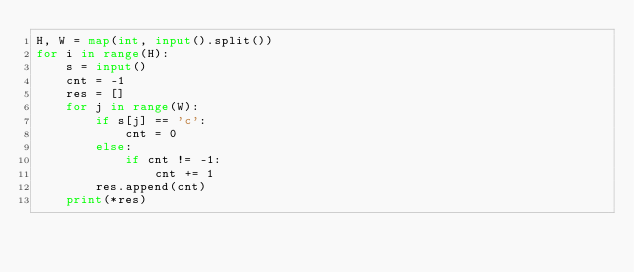<code> <loc_0><loc_0><loc_500><loc_500><_Python_>H, W = map(int, input().split())
for i in range(H):
    s = input()
    cnt = -1
    res = []
    for j in range(W):
        if s[j] == 'c':
            cnt = 0
        else:
            if cnt != -1:
                cnt += 1
        res.append(cnt)
    print(*res)</code> 